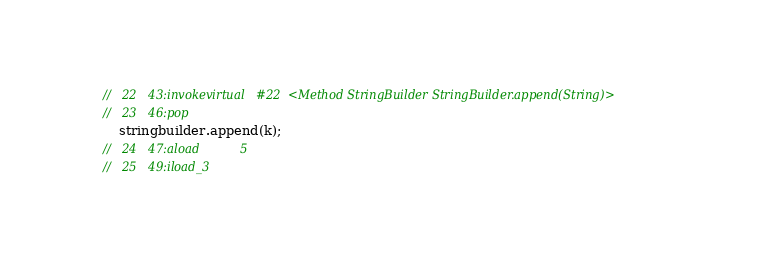Convert code to text. <code><loc_0><loc_0><loc_500><loc_500><_Java_>	//   22   43:invokevirtual   #22  <Method StringBuilder StringBuilder.append(String)>
	//   23   46:pop             
		stringbuilder.append(k);
	//   24   47:aload           5
	//   25   49:iload_3         </code> 